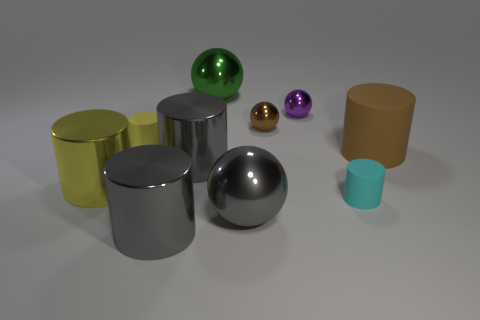Subtract all big green balls. How many balls are left? 3 Subtract all yellow cubes. How many yellow cylinders are left? 2 Subtract 2 spheres. How many spheres are left? 2 Subtract all gray cylinders. How many cylinders are left? 4 Subtract all balls. How many objects are left? 6 Subtract all yellow matte cylinders. Subtract all purple metal balls. How many objects are left? 8 Add 7 tiny matte cylinders. How many tiny matte cylinders are left? 9 Add 7 large green matte cylinders. How many large green matte cylinders exist? 7 Subtract 0 red balls. How many objects are left? 10 Subtract all brown cylinders. Subtract all blue blocks. How many cylinders are left? 5 